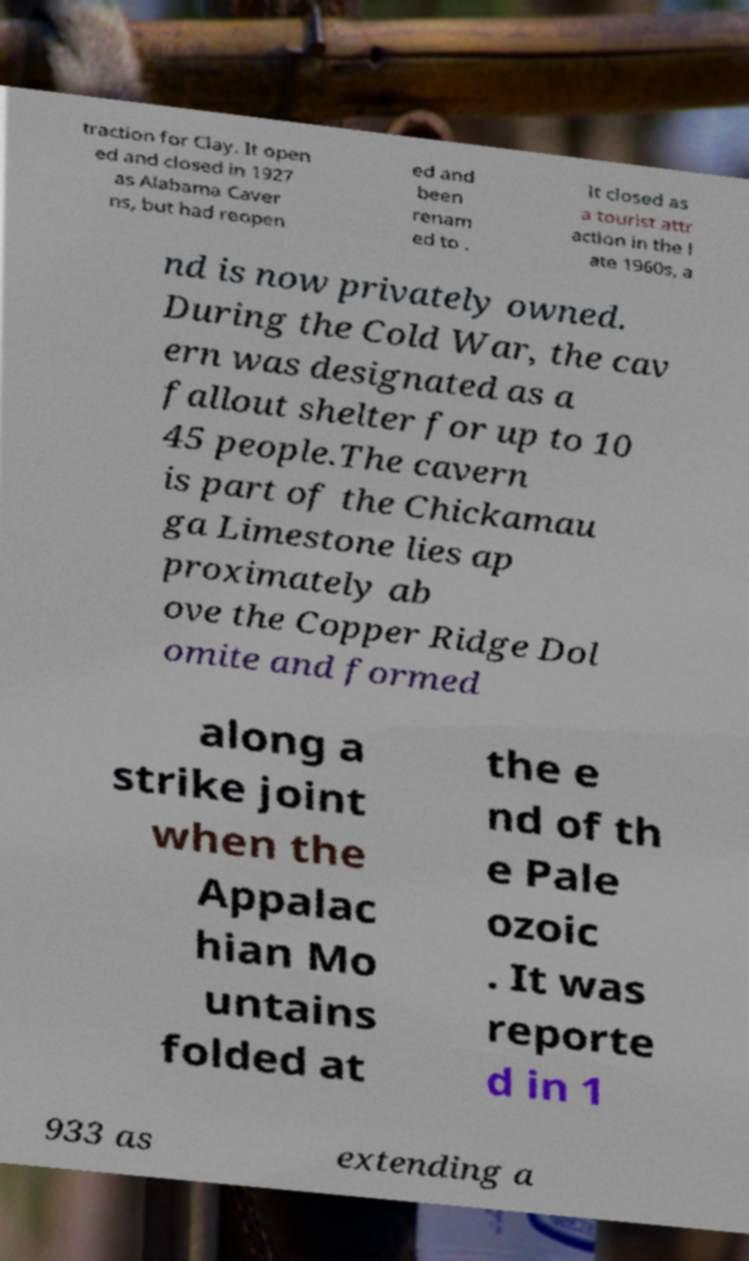Can you accurately transcribe the text from the provided image for me? traction for Clay. It open ed and closed in 1927 as Alabama Caver ns, but had reopen ed and been renam ed to . It closed as a tourist attr action in the l ate 1960s, a nd is now privately owned. During the Cold War, the cav ern was designated as a fallout shelter for up to 10 45 people.The cavern is part of the Chickamau ga Limestone lies ap proximately ab ove the Copper Ridge Dol omite and formed along a strike joint when the Appalac hian Mo untains folded at the e nd of th e Pale ozoic . It was reporte d in 1 933 as extending a 